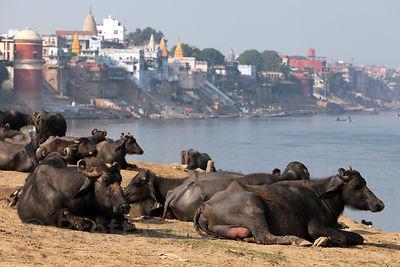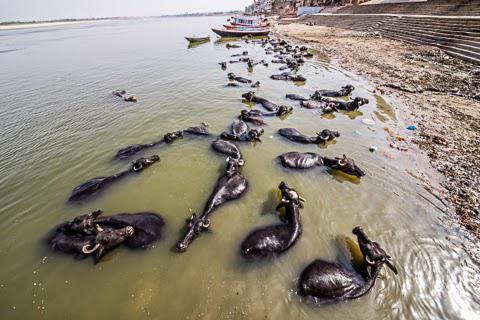The first image is the image on the left, the second image is the image on the right. Analyze the images presented: Is the assertion "In at least one image there is a single man with short hair to the left of a horned ox." valid? Answer yes or no. No. The first image is the image on the left, the second image is the image on the right. Assess this claim about the two images: "One image includes a person standing by a water buffalo in a wet area, and the other image shows one person in blue standing by water buffalo on dry ground.". Correct or not? Answer yes or no. No. 